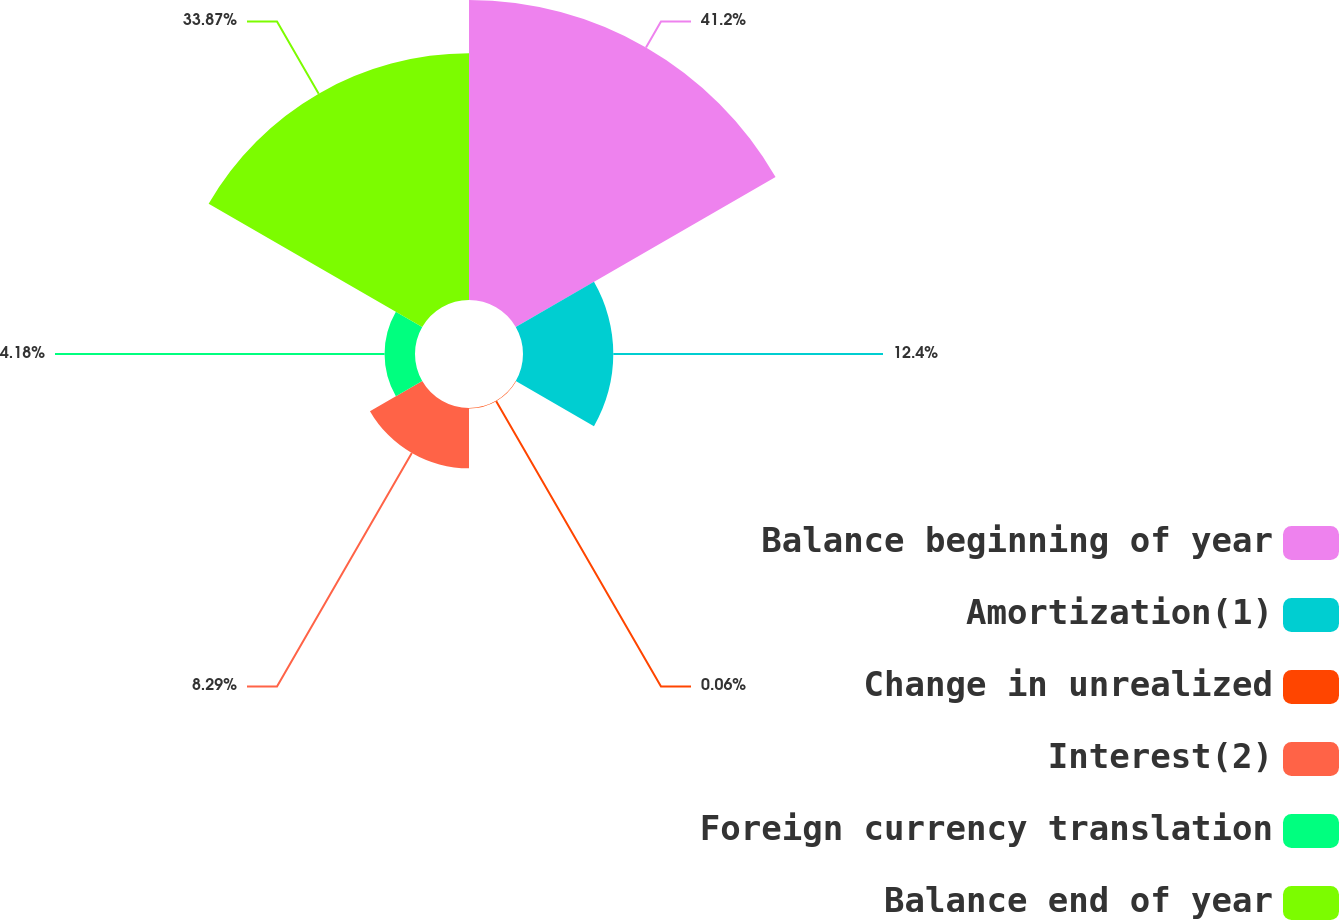Convert chart. <chart><loc_0><loc_0><loc_500><loc_500><pie_chart><fcel>Balance beginning of year<fcel>Amortization(1)<fcel>Change in unrealized<fcel>Interest(2)<fcel>Foreign currency translation<fcel>Balance end of year<nl><fcel>41.2%<fcel>12.4%<fcel>0.06%<fcel>8.29%<fcel>4.18%<fcel>33.87%<nl></chart> 